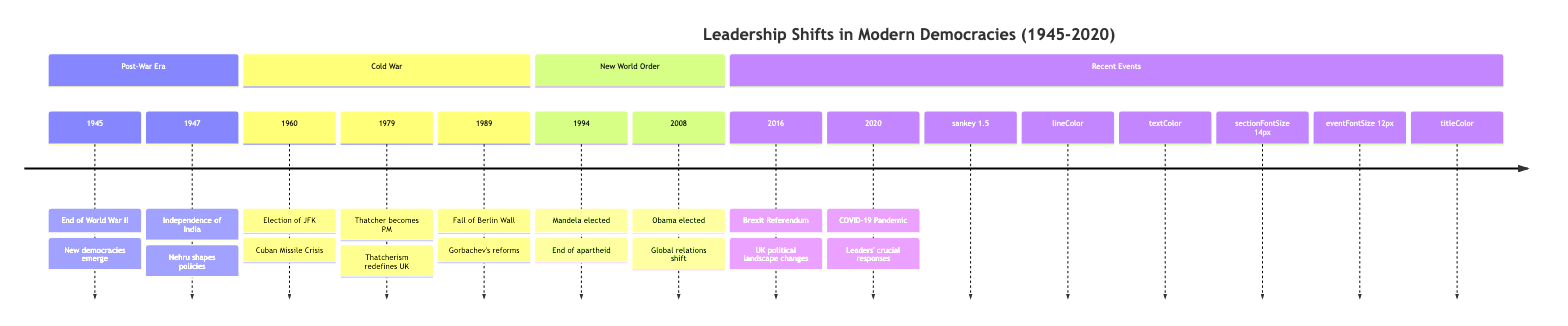What year marks the end of World War II? According to the timeline, the event "End of World War II" is listed under the year 1945. Therefore, the timeline indicates that 1945 is the year marking the end of World War II.
Answer: 1945 Who became Prime Minister of the UK in 1979? The timeline states that in 1979, "Margaret Thatcher becomes Prime Minister." Thus, the answer is explicitly found in the event description for that year.
Answer: Margaret Thatcher Which leader played a crucial role in the independence of India? The timeline cites Jawaharlal Nehru as the leader who "plays a crucial role in defining India's foreign and domestic policies" post-independence in 1947. Therefore, he is the answer.
Answer: Jawaharlal Nehru How many significant political events occurred during the Cold War section? In the Cold War section, there are three events listed: the election of JFK in 1960, Thatcher becoming PM in 1979, and the fall of the Berlin Wall in 1989. Counting these events gives us the answer.
Answer: 3 What major global event was associated with the year 2020? The timeline describes the COVID-19 Pandemic as the major global event occurring in the year 2020. The description indicates this significant crisis.
Answer: COVID-19 Pandemic Who was the leader during the Brexit Referendum in 2016? The event description for 2016 directly mentions "David Cameron's decision to hold the referendum," indicating he was the leader during that time.
Answer: David Cameron Which event is described as marking the end of apartheid? The timeline states that the "Election of Nelson Mandela" in 1994 marks the end of apartheid, making this description clear.
Answer: Election of Nelson Mandela What significant shift did Barack Obama's election in 2008 bring? According to the timeline, the description for Obama's election in 2008 indicates a shift in "global relations," which signifies the importance of this event.
Answer: Global relations shift What change in leadership occurred following the fall of the Berlin Wall? The timeline indicates that Mikhail Gorbachev's policies led to significant political changes in Eastern Europe after the fall of the Berlin Wall in 1989, highlighting the role of leadership.
Answer: Gorbachev's policies 